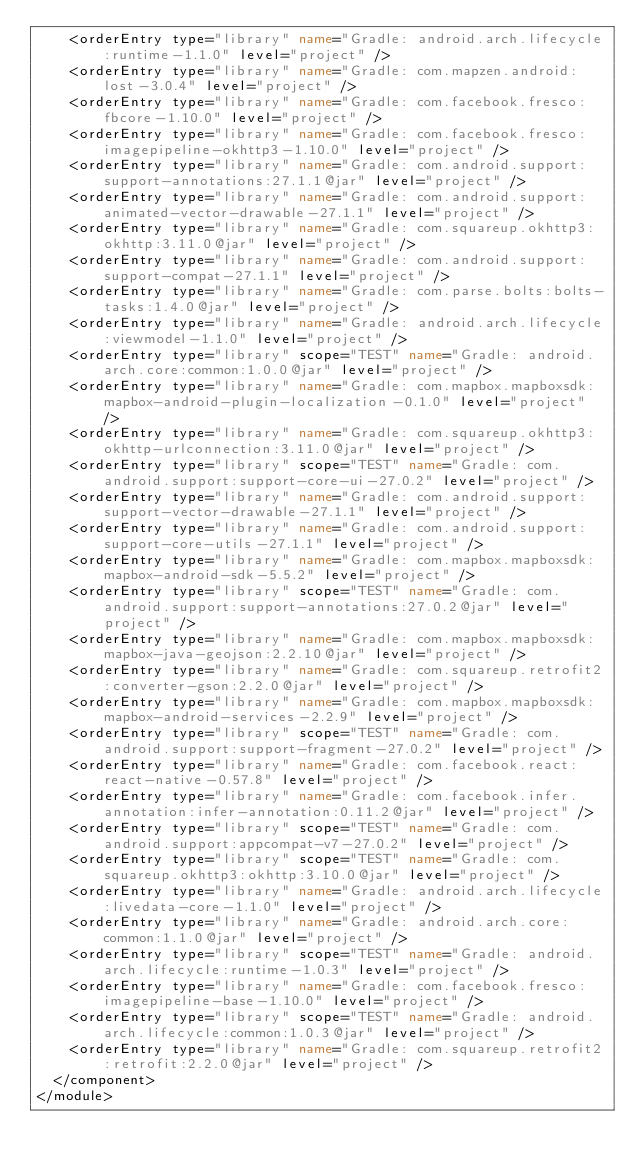<code> <loc_0><loc_0><loc_500><loc_500><_XML_>    <orderEntry type="library" name="Gradle: android.arch.lifecycle:runtime-1.1.0" level="project" />
    <orderEntry type="library" name="Gradle: com.mapzen.android:lost-3.0.4" level="project" />
    <orderEntry type="library" name="Gradle: com.facebook.fresco:fbcore-1.10.0" level="project" />
    <orderEntry type="library" name="Gradle: com.facebook.fresco:imagepipeline-okhttp3-1.10.0" level="project" />
    <orderEntry type="library" name="Gradle: com.android.support:support-annotations:27.1.1@jar" level="project" />
    <orderEntry type="library" name="Gradle: com.android.support:animated-vector-drawable-27.1.1" level="project" />
    <orderEntry type="library" name="Gradle: com.squareup.okhttp3:okhttp:3.11.0@jar" level="project" />
    <orderEntry type="library" name="Gradle: com.android.support:support-compat-27.1.1" level="project" />
    <orderEntry type="library" name="Gradle: com.parse.bolts:bolts-tasks:1.4.0@jar" level="project" />
    <orderEntry type="library" name="Gradle: android.arch.lifecycle:viewmodel-1.1.0" level="project" />
    <orderEntry type="library" scope="TEST" name="Gradle: android.arch.core:common:1.0.0@jar" level="project" />
    <orderEntry type="library" name="Gradle: com.mapbox.mapboxsdk:mapbox-android-plugin-localization-0.1.0" level="project" />
    <orderEntry type="library" name="Gradle: com.squareup.okhttp3:okhttp-urlconnection:3.11.0@jar" level="project" />
    <orderEntry type="library" scope="TEST" name="Gradle: com.android.support:support-core-ui-27.0.2" level="project" />
    <orderEntry type="library" name="Gradle: com.android.support:support-vector-drawable-27.1.1" level="project" />
    <orderEntry type="library" name="Gradle: com.android.support:support-core-utils-27.1.1" level="project" />
    <orderEntry type="library" name="Gradle: com.mapbox.mapboxsdk:mapbox-android-sdk-5.5.2" level="project" />
    <orderEntry type="library" scope="TEST" name="Gradle: com.android.support:support-annotations:27.0.2@jar" level="project" />
    <orderEntry type="library" name="Gradle: com.mapbox.mapboxsdk:mapbox-java-geojson:2.2.10@jar" level="project" />
    <orderEntry type="library" name="Gradle: com.squareup.retrofit2:converter-gson:2.2.0@jar" level="project" />
    <orderEntry type="library" name="Gradle: com.mapbox.mapboxsdk:mapbox-android-services-2.2.9" level="project" />
    <orderEntry type="library" scope="TEST" name="Gradle: com.android.support:support-fragment-27.0.2" level="project" />
    <orderEntry type="library" name="Gradle: com.facebook.react:react-native-0.57.8" level="project" />
    <orderEntry type="library" name="Gradle: com.facebook.infer.annotation:infer-annotation:0.11.2@jar" level="project" />
    <orderEntry type="library" scope="TEST" name="Gradle: com.android.support:appcompat-v7-27.0.2" level="project" />
    <orderEntry type="library" scope="TEST" name="Gradle: com.squareup.okhttp3:okhttp:3.10.0@jar" level="project" />
    <orderEntry type="library" name="Gradle: android.arch.lifecycle:livedata-core-1.1.0" level="project" />
    <orderEntry type="library" name="Gradle: android.arch.core:common:1.1.0@jar" level="project" />
    <orderEntry type="library" scope="TEST" name="Gradle: android.arch.lifecycle:runtime-1.0.3" level="project" />
    <orderEntry type="library" name="Gradle: com.facebook.fresco:imagepipeline-base-1.10.0" level="project" />
    <orderEntry type="library" scope="TEST" name="Gradle: android.arch.lifecycle:common:1.0.3@jar" level="project" />
    <orderEntry type="library" name="Gradle: com.squareup.retrofit2:retrofit:2.2.0@jar" level="project" />
  </component>
</module></code> 